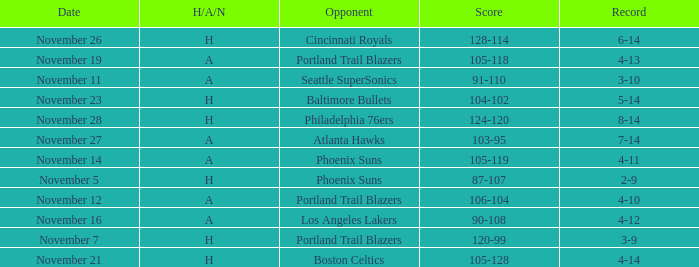On what Date was the Score 105-118 and the H/A/N A? November 19. 